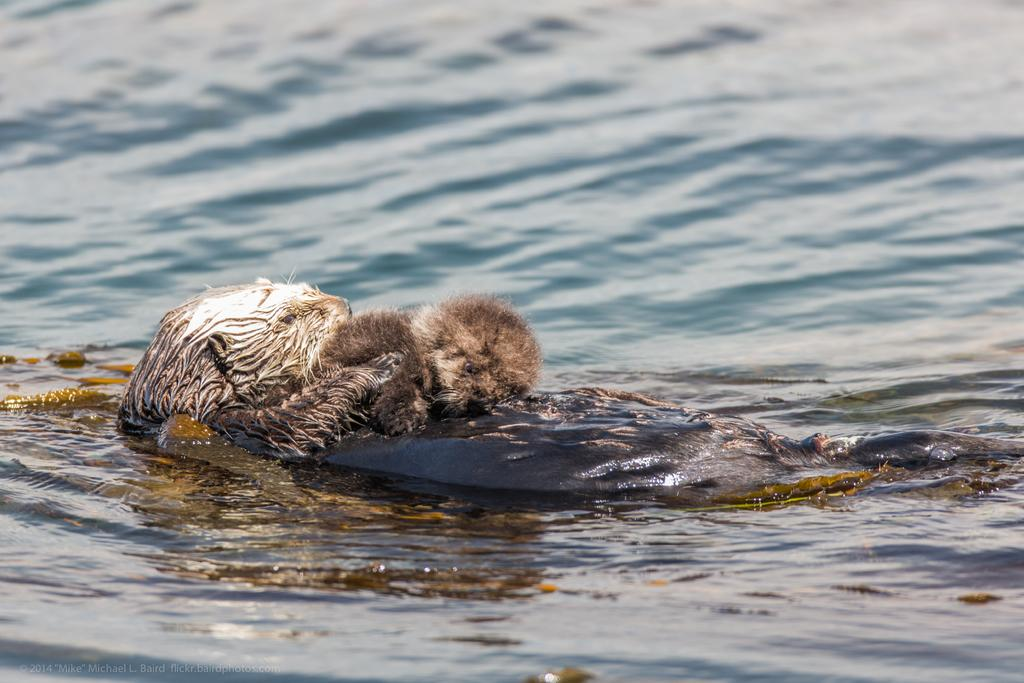How many animals are present in the image? There are two animals in the image. What is the color of the object on which the animals are sitting? The object is black-colored. Where is the black-colored object located? The black-colored object is in the water. Can you see any fairies flying around the animals in the image? There are no fairies present in the image. What type of wheel is attached to the animals in the image? There is no wheel attached to the animals in the image. 